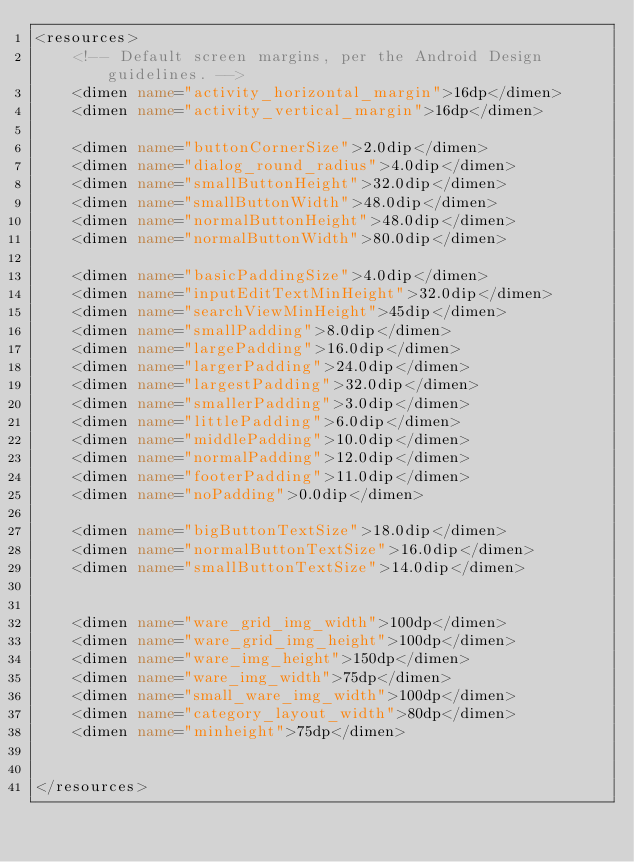<code> <loc_0><loc_0><loc_500><loc_500><_XML_><resources>
    <!-- Default screen margins, per the Android Design guidelines. -->
    <dimen name="activity_horizontal_margin">16dp</dimen>
    <dimen name="activity_vertical_margin">16dp</dimen>

    <dimen name="buttonCornerSize">2.0dip</dimen>
    <dimen name="dialog_round_radius">4.0dip</dimen>
    <dimen name="smallButtonHeight">32.0dip</dimen>
    <dimen name="smallButtonWidth">48.0dip</dimen>
    <dimen name="normalButtonHeight">48.0dip</dimen>
    <dimen name="normalButtonWidth">80.0dip</dimen>

    <dimen name="basicPaddingSize">4.0dip</dimen>
    <dimen name="inputEditTextMinHeight">32.0dip</dimen>
    <dimen name="searchViewMinHeight">45dip</dimen>
    <dimen name="smallPadding">8.0dip</dimen>
    <dimen name="largePadding">16.0dip</dimen>
    <dimen name="largerPadding">24.0dip</dimen>
    <dimen name="largestPadding">32.0dip</dimen>
    <dimen name="smallerPadding">3.0dip</dimen>
    <dimen name="littlePadding">6.0dip</dimen>
    <dimen name="middlePadding">10.0dip</dimen>
    <dimen name="normalPadding">12.0dip</dimen>
    <dimen name="footerPadding">11.0dip</dimen>
    <dimen name="noPadding">0.0dip</dimen>

    <dimen name="bigButtonTextSize">18.0dip</dimen>
    <dimen name="normalButtonTextSize">16.0dip</dimen>
    <dimen name="smallButtonTextSize">14.0dip</dimen>


    <dimen name="ware_grid_img_width">100dp</dimen>
    <dimen name="ware_grid_img_height">100dp</dimen>
    <dimen name="ware_img_height">150dp</dimen>
    <dimen name="ware_img_width">75dp</dimen>
    <dimen name="small_ware_img_width">100dp</dimen>
    <dimen name="category_layout_width">80dp</dimen>
    <dimen name="minheight">75dp</dimen>


</resources>
</code> 